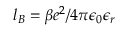Convert formula to latex. <formula><loc_0><loc_0><loc_500><loc_500>l _ { B } = \beta e ^ { 2 } / 4 \pi \epsilon _ { 0 } \epsilon _ { r }</formula> 